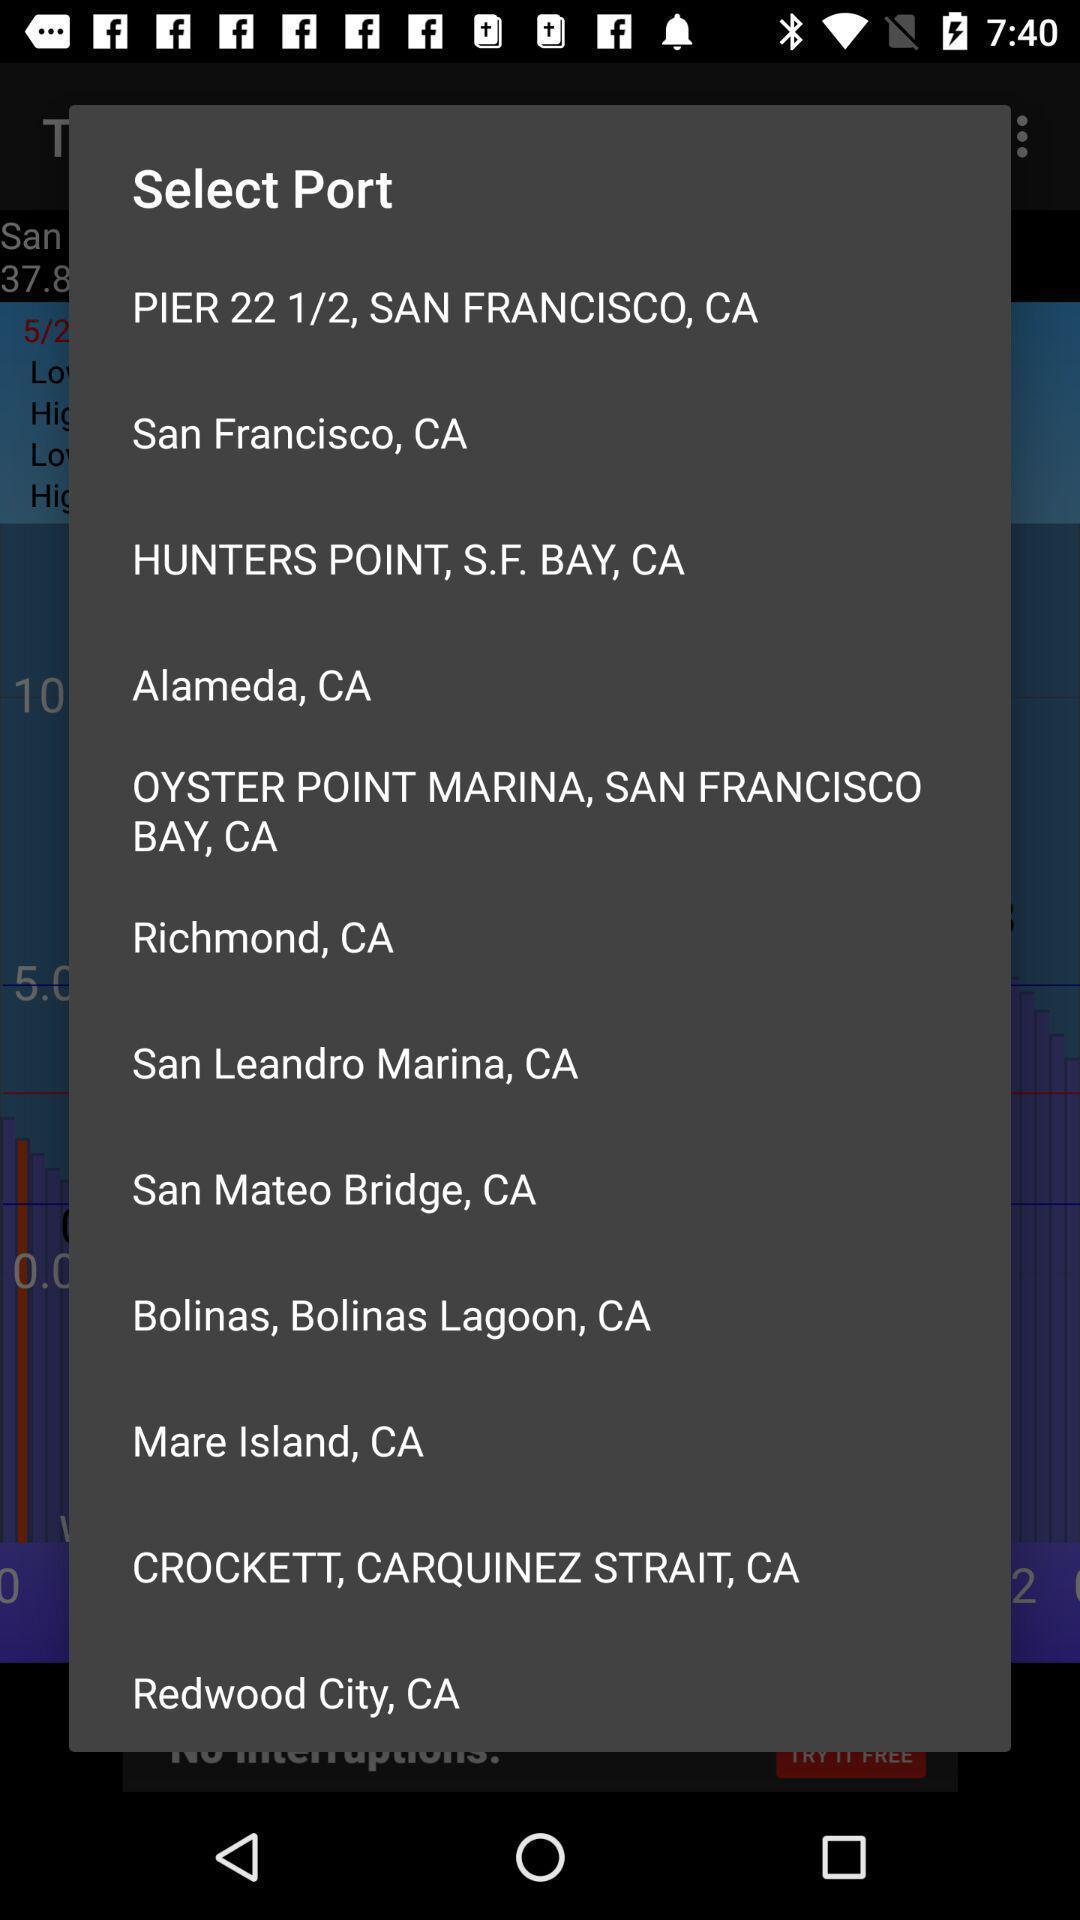Summarize the main components in this picture. Popup to select port in a weather app. 